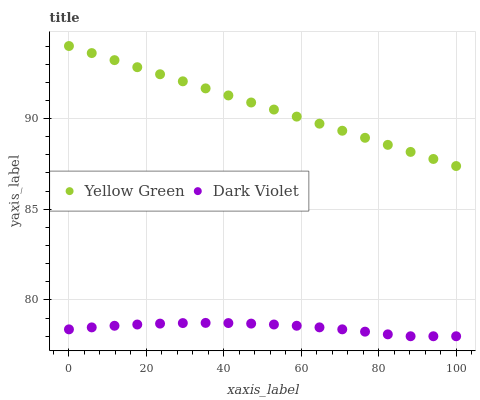Does Dark Violet have the minimum area under the curve?
Answer yes or no. Yes. Does Yellow Green have the maximum area under the curve?
Answer yes or no. Yes. Does Dark Violet have the maximum area under the curve?
Answer yes or no. No. Is Yellow Green the smoothest?
Answer yes or no. Yes. Is Dark Violet the roughest?
Answer yes or no. Yes. Is Dark Violet the smoothest?
Answer yes or no. No. Does Dark Violet have the lowest value?
Answer yes or no. Yes. Does Yellow Green have the highest value?
Answer yes or no. Yes. Does Dark Violet have the highest value?
Answer yes or no. No. Is Dark Violet less than Yellow Green?
Answer yes or no. Yes. Is Yellow Green greater than Dark Violet?
Answer yes or no. Yes. Does Dark Violet intersect Yellow Green?
Answer yes or no. No. 